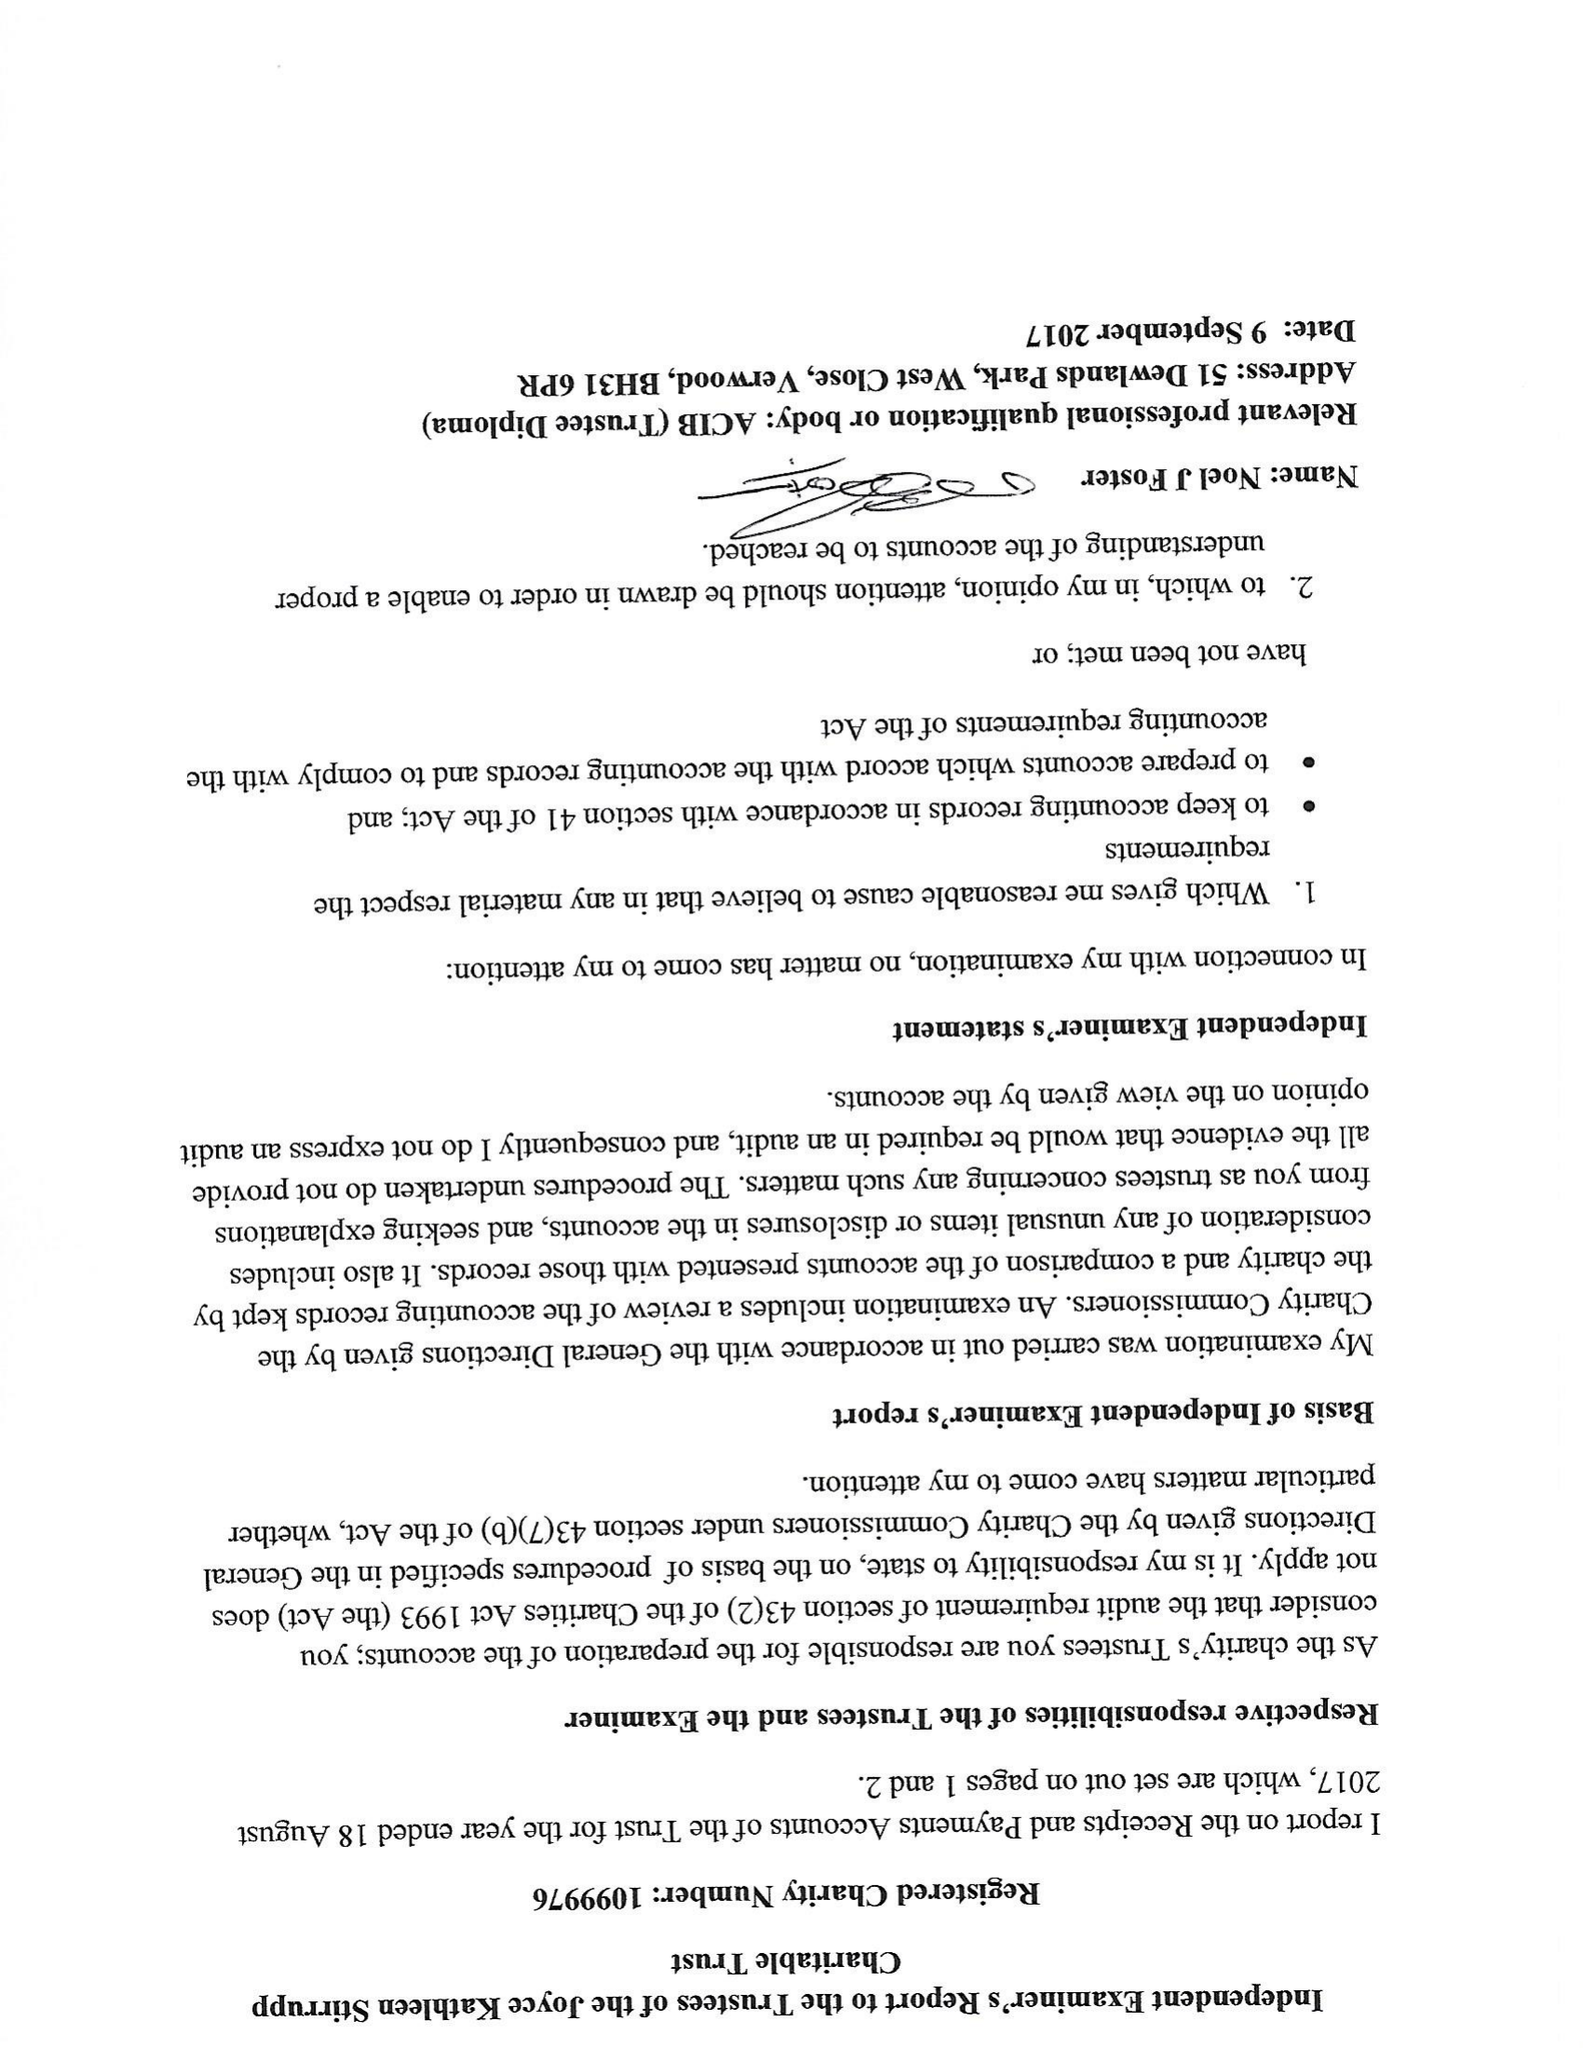What is the value for the address__post_town?
Answer the question using a single word or phrase. BRISTOL 